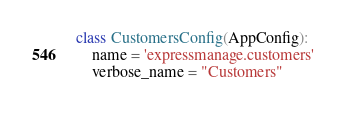Convert code to text. <code><loc_0><loc_0><loc_500><loc_500><_Python_>

class CustomersConfig(AppConfig):
    name = 'expressmanage.customers'
    verbose_name = "Customers"
</code> 